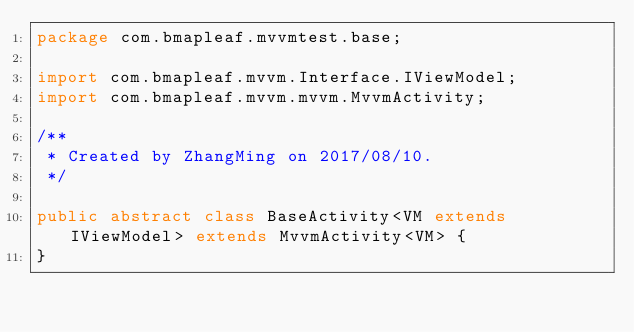Convert code to text. <code><loc_0><loc_0><loc_500><loc_500><_Java_>package com.bmapleaf.mvvmtest.base;

import com.bmapleaf.mvvm.Interface.IViewModel;
import com.bmapleaf.mvvm.mvvm.MvvmActivity;

/**
 * Created by ZhangMing on 2017/08/10.
 */

public abstract class BaseActivity<VM extends IViewModel> extends MvvmActivity<VM> {
}
</code> 